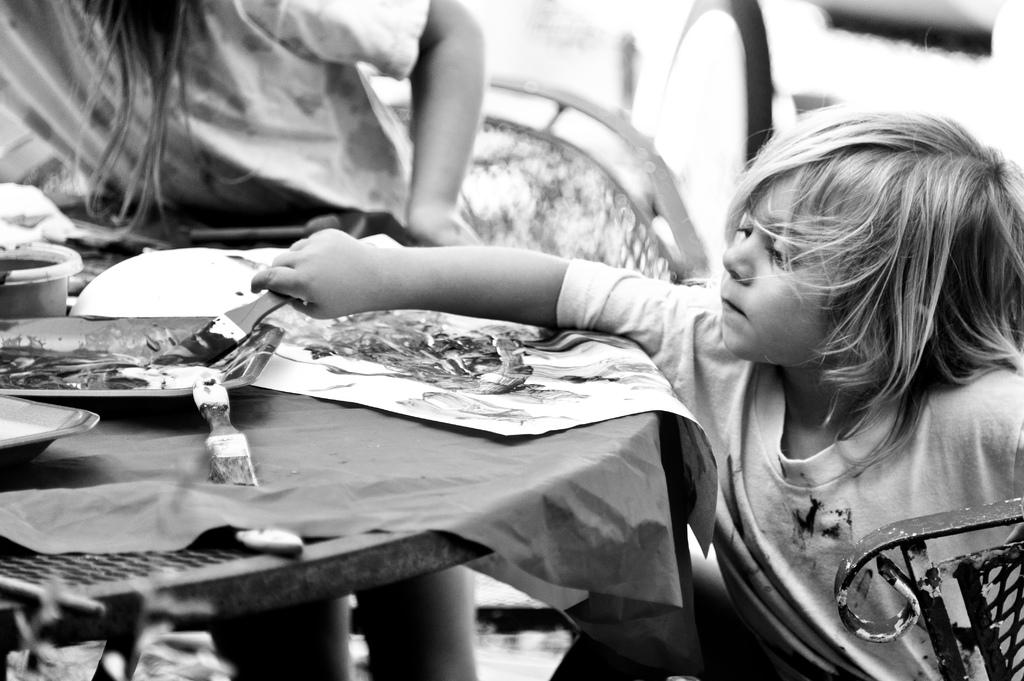Who is present in the image? There is a child and a person in the image. What are they doing in the image? Both the child and the person are in front of a table. What is the child holding in his hand? The child is holding an object in his hand. What else can be seen on the table? There are other objects on the table. What type of watch is the child wearing in the image? There is no watch visible on the child in the image. Is the person in the image a prisoner? There is no indication in the image that the person is a prisoner. 